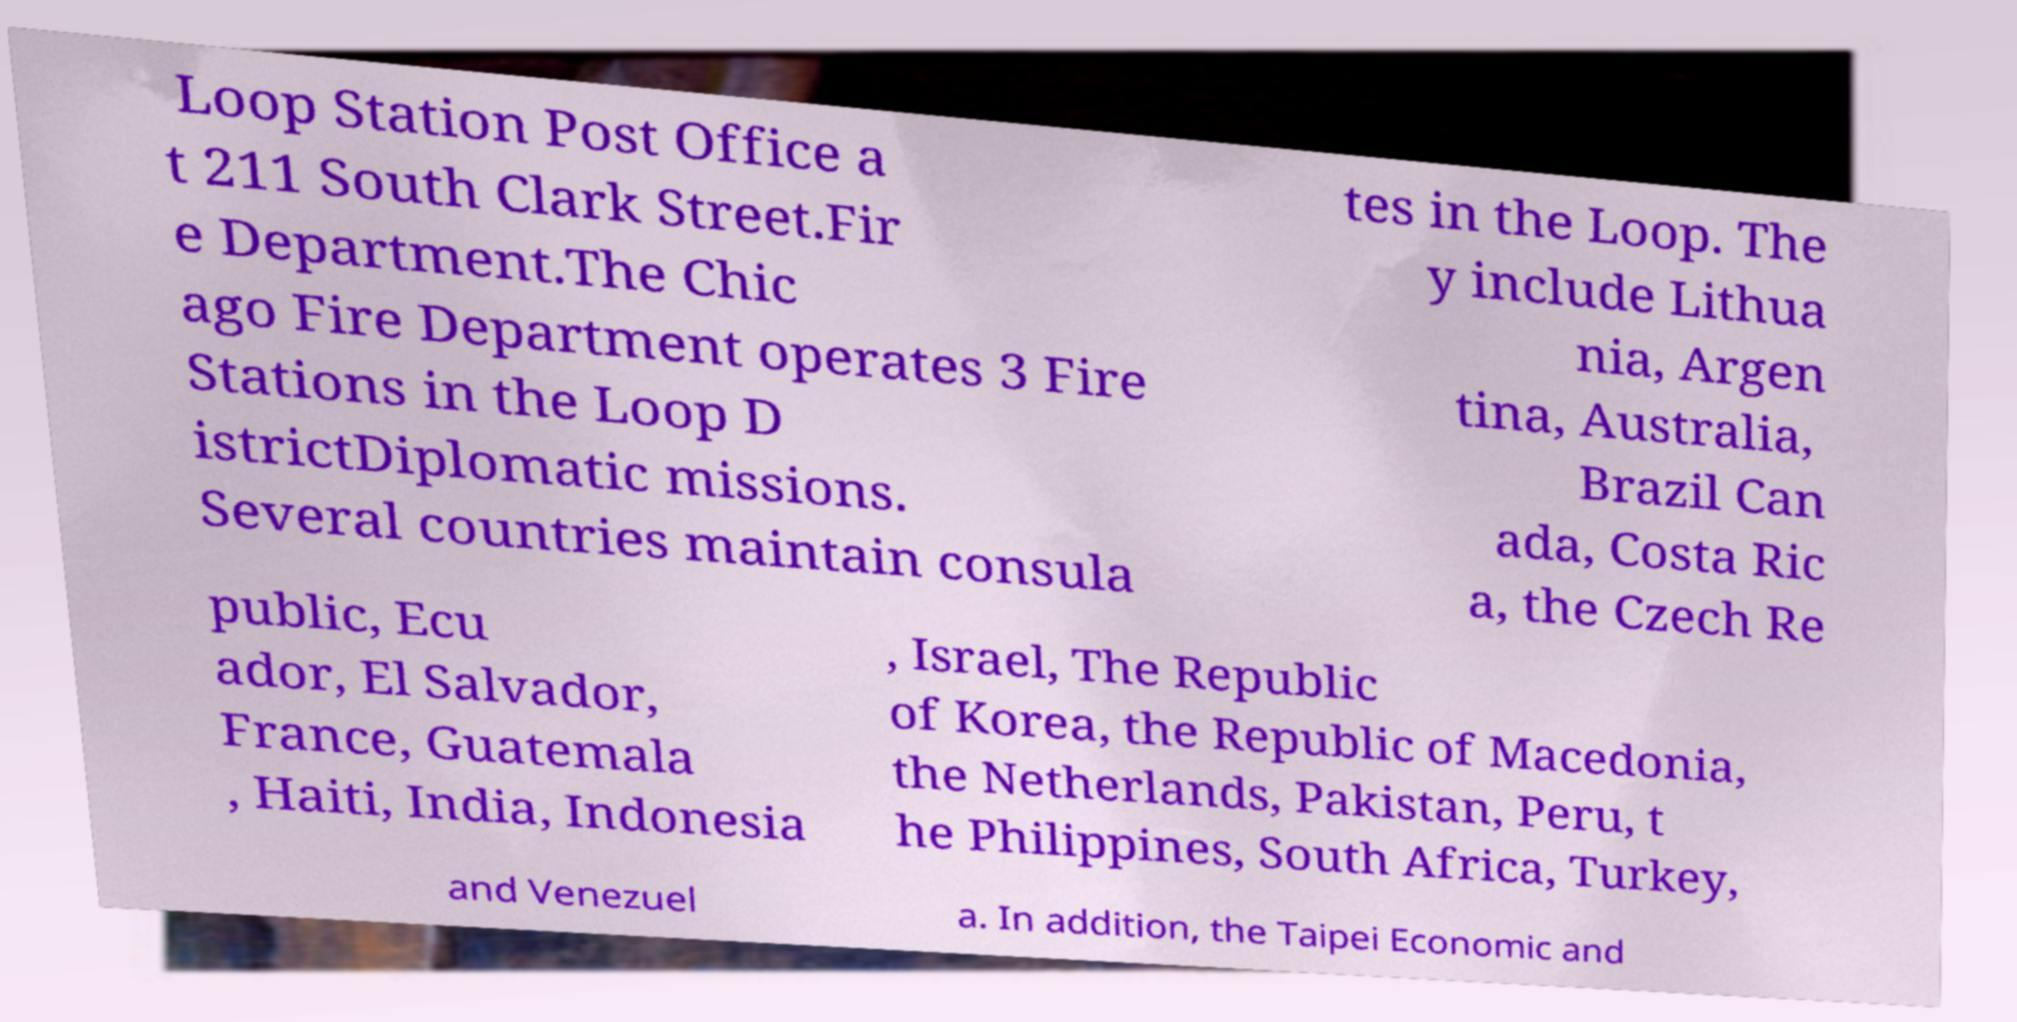I need the written content from this picture converted into text. Can you do that? Loop Station Post Office a t 211 South Clark Street.Fir e Department.The Chic ago Fire Department operates 3 Fire Stations in the Loop D istrictDiplomatic missions. Several countries maintain consula tes in the Loop. The y include Lithua nia, Argen tina, Australia, Brazil Can ada, Costa Ric a, the Czech Re public, Ecu ador, El Salvador, France, Guatemala , Haiti, India, Indonesia , Israel, The Republic of Korea, the Republic of Macedonia, the Netherlands, Pakistan, Peru, t he Philippines, South Africa, Turkey, and Venezuel a. In addition, the Taipei Economic and 